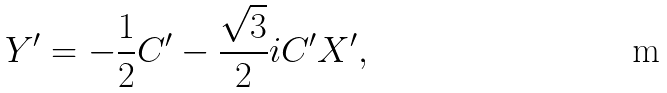Convert formula to latex. <formula><loc_0><loc_0><loc_500><loc_500>Y ^ { \prime } = - \frac { 1 } { 2 } C ^ { \prime } - \frac { \sqrt { 3 } } { 2 } i C ^ { \prime } X ^ { \prime } ,</formula> 